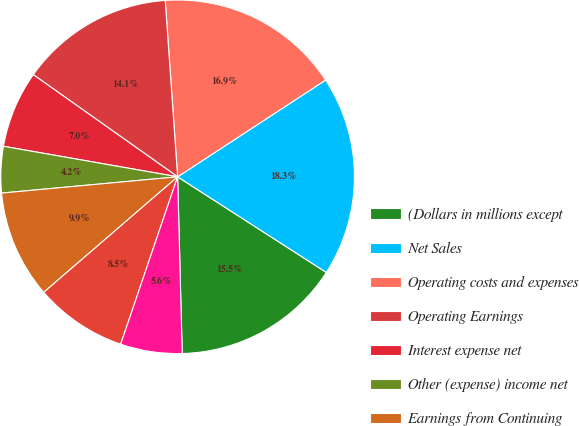<chart> <loc_0><loc_0><loc_500><loc_500><pie_chart><fcel>(Dollars in millions except<fcel>Net Sales<fcel>Operating costs and expenses<fcel>Operating Earnings<fcel>Interest expense net<fcel>Other (expense) income net<fcel>Earnings from Continuing<fcel>Provision for income taxes net<fcel>Discontinued operations net of<nl><fcel>15.49%<fcel>18.31%<fcel>16.9%<fcel>14.08%<fcel>7.04%<fcel>4.23%<fcel>9.86%<fcel>8.45%<fcel>5.63%<nl></chart> 